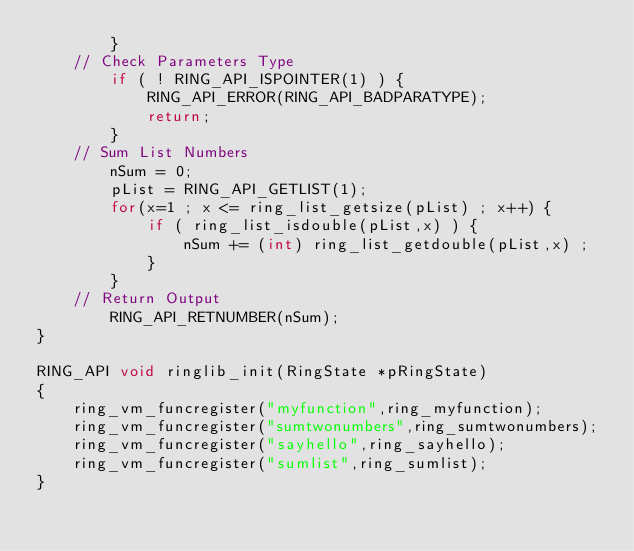<code> <loc_0><loc_0><loc_500><loc_500><_C_>		}
	// Check Parameters Type
		if ( ! RING_API_ISPOINTER(1) ) {
			RING_API_ERROR(RING_API_BADPARATYPE);
			return;
		}
	// Sum List Numbers 
		nSum = 0;
		pList = RING_API_GETLIST(1);
		for(x=1 ; x <= ring_list_getsize(pList) ; x++) {
			if ( ring_list_isdouble(pList,x) ) {
				nSum += (int) ring_list_getdouble(pList,x) ;
			}
		}
	// Return Output 
		RING_API_RETNUMBER(nSum);
}

RING_API void ringlib_init(RingState *pRingState)
{
	ring_vm_funcregister("myfunction",ring_myfunction);
	ring_vm_funcregister("sumtwonumbers",ring_sumtwonumbers);
	ring_vm_funcregister("sayhello",ring_sayhello);
	ring_vm_funcregister("sumlist",ring_sumlist);
}
</code> 